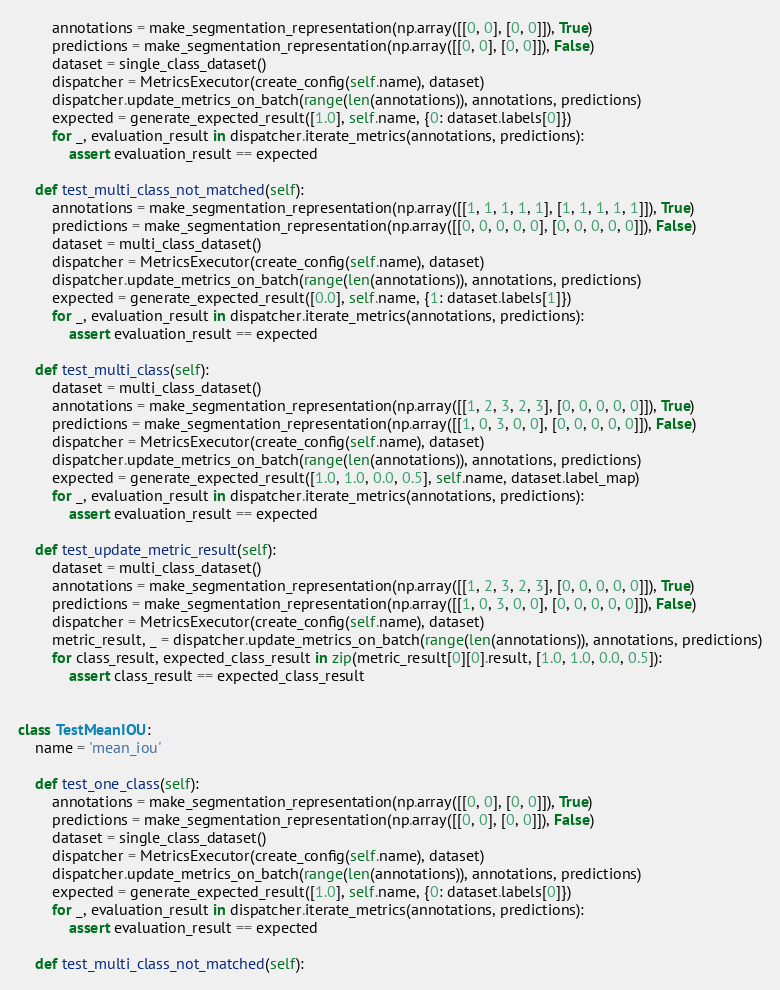Convert code to text. <code><loc_0><loc_0><loc_500><loc_500><_Python_>        annotations = make_segmentation_representation(np.array([[0, 0], [0, 0]]), True)
        predictions = make_segmentation_representation(np.array([[0, 0], [0, 0]]), False)
        dataset = single_class_dataset()
        dispatcher = MetricsExecutor(create_config(self.name), dataset)
        dispatcher.update_metrics_on_batch(range(len(annotations)), annotations, predictions)
        expected = generate_expected_result([1.0], self.name, {0: dataset.labels[0]})
        for _, evaluation_result in dispatcher.iterate_metrics(annotations, predictions):
            assert evaluation_result == expected

    def test_multi_class_not_matched(self):
        annotations = make_segmentation_representation(np.array([[1, 1, 1, 1, 1], [1, 1, 1, 1, 1]]), True)
        predictions = make_segmentation_representation(np.array([[0, 0, 0, 0, 0], [0, 0, 0, 0, 0]]), False)
        dataset = multi_class_dataset()
        dispatcher = MetricsExecutor(create_config(self.name), dataset)
        dispatcher.update_metrics_on_batch(range(len(annotations)), annotations, predictions)
        expected = generate_expected_result([0.0], self.name, {1: dataset.labels[1]})
        for _, evaluation_result in dispatcher.iterate_metrics(annotations, predictions):
            assert evaluation_result == expected

    def test_multi_class(self):
        dataset = multi_class_dataset()
        annotations = make_segmentation_representation(np.array([[1, 2, 3, 2, 3], [0, 0, 0, 0, 0]]), True)
        predictions = make_segmentation_representation(np.array([[1, 0, 3, 0, 0], [0, 0, 0, 0, 0]]), False)
        dispatcher = MetricsExecutor(create_config(self.name), dataset)
        dispatcher.update_metrics_on_batch(range(len(annotations)), annotations, predictions)
        expected = generate_expected_result([1.0, 1.0, 0.0, 0.5], self.name, dataset.label_map)
        for _, evaluation_result in dispatcher.iterate_metrics(annotations, predictions):
            assert evaluation_result == expected

    def test_update_metric_result(self):
        dataset = multi_class_dataset()
        annotations = make_segmentation_representation(np.array([[1, 2, 3, 2, 3], [0, 0, 0, 0, 0]]), True)
        predictions = make_segmentation_representation(np.array([[1, 0, 3, 0, 0], [0, 0, 0, 0, 0]]), False)
        dispatcher = MetricsExecutor(create_config(self.name), dataset)
        metric_result, _ = dispatcher.update_metrics_on_batch(range(len(annotations)), annotations, predictions)
        for class_result, expected_class_result in zip(metric_result[0][0].result, [1.0, 1.0, 0.0, 0.5]):
            assert class_result == expected_class_result


class TestMeanIOU:
    name = 'mean_iou'

    def test_one_class(self):
        annotations = make_segmentation_representation(np.array([[0, 0], [0, 0]]), True)
        predictions = make_segmentation_representation(np.array([[0, 0], [0, 0]]), False)
        dataset = single_class_dataset()
        dispatcher = MetricsExecutor(create_config(self.name), dataset)
        dispatcher.update_metrics_on_batch(range(len(annotations)), annotations, predictions)
        expected = generate_expected_result([1.0], self.name, {0: dataset.labels[0]})
        for _, evaluation_result in dispatcher.iterate_metrics(annotations, predictions):
            assert evaluation_result == expected

    def test_multi_class_not_matched(self):</code> 